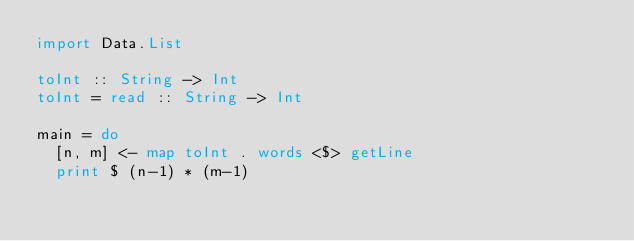Convert code to text. <code><loc_0><loc_0><loc_500><loc_500><_Haskell_>import Data.List

toInt :: String -> Int
toInt = read :: String -> Int

main = do
  [n, m] <- map toInt . words <$> getLine
  print $ (n-1) * (m-1)
</code> 